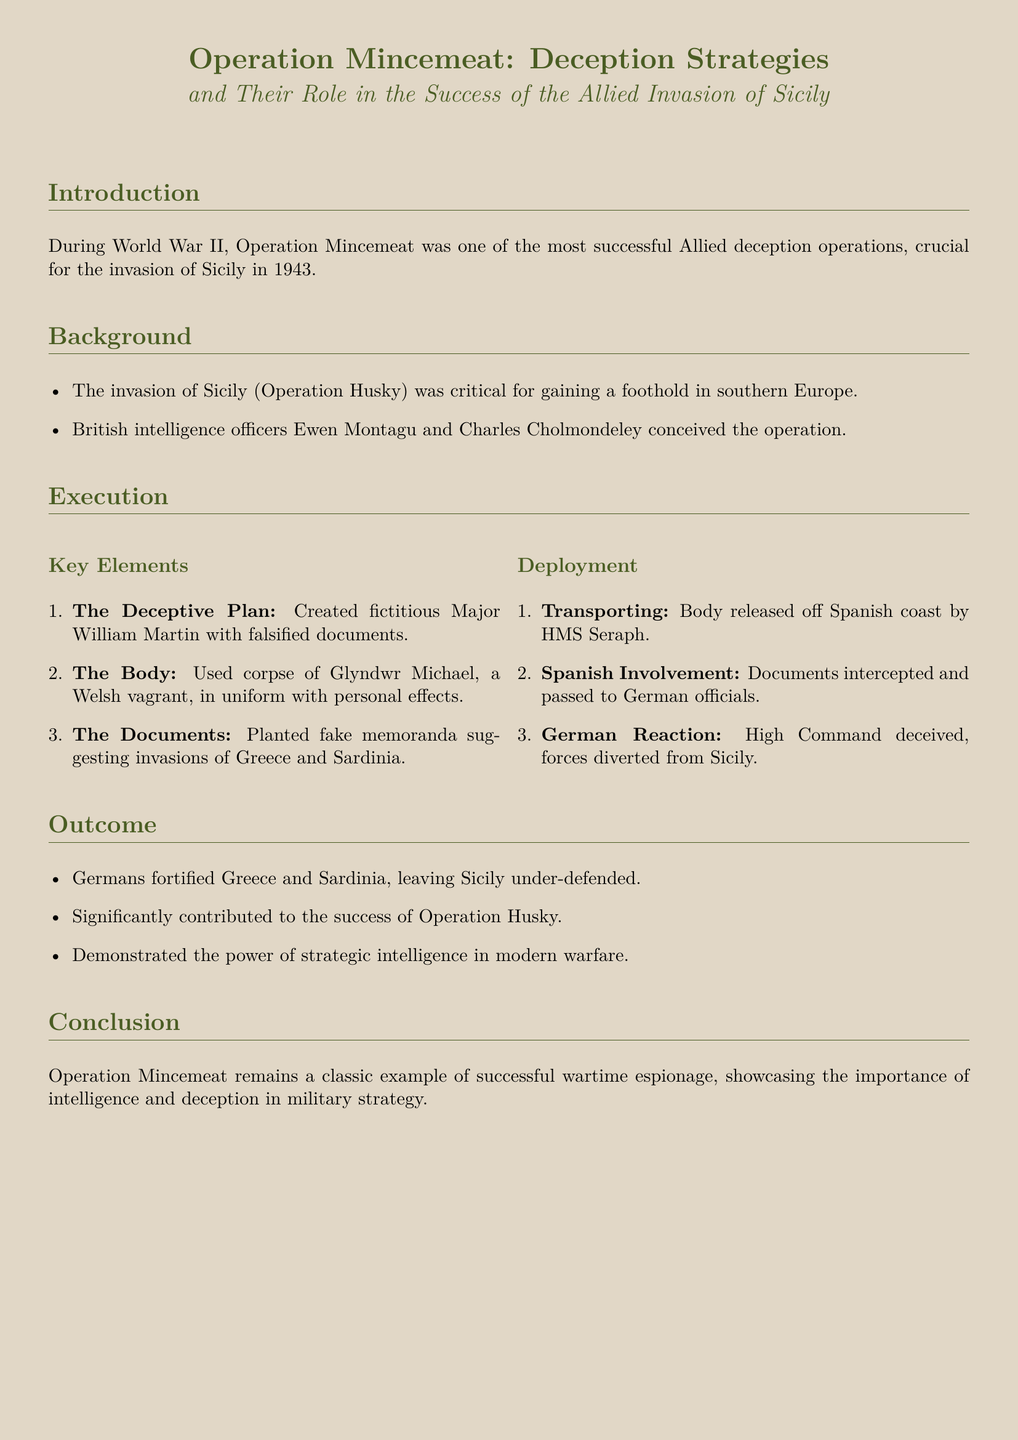What was Operation Mincemeat? Operation Mincemeat was one of the most successful Allied deception operations during World War II.
Answer: Allied deception operation Who conceived the operation? British intelligence officers Ewen Montagu and Charles Cholmondeley conceived the operation.
Answer: Ewen Montagu and Charles Cholmondeley What fictitious identity was created for the operation? The operation created a fictitious Major William Martin with falsified documents.
Answer: Major William Martin What was used as the body for the operation? The corpse of Glyndwr Michael, a Welsh vagrant, was used in the operation.
Answer: Glyndwr Michael What was the main purpose of the planted documents? The planted documents suggested invasions of Greece and Sardinia.
Answer: Greece and Sardinia What was the result of the Germans' actions following the operation? Germans fortified Greece and Sardinia, leaving Sicily under-defended.
Answer: Sicily under-defended What military operation did Operation Mincemeat support? It significantly contributed to the success of Operation Husky.
Answer: Operation Husky What year did Operation Mincemeat take place? Operation Mincemeat was crucial for the invasion of Sicily in 1943.
Answer: 1943 What was demonstrated by Operation Mincemeat's success? It demonstrated the power of strategic intelligence in modern warfare.
Answer: Strategic intelligence 